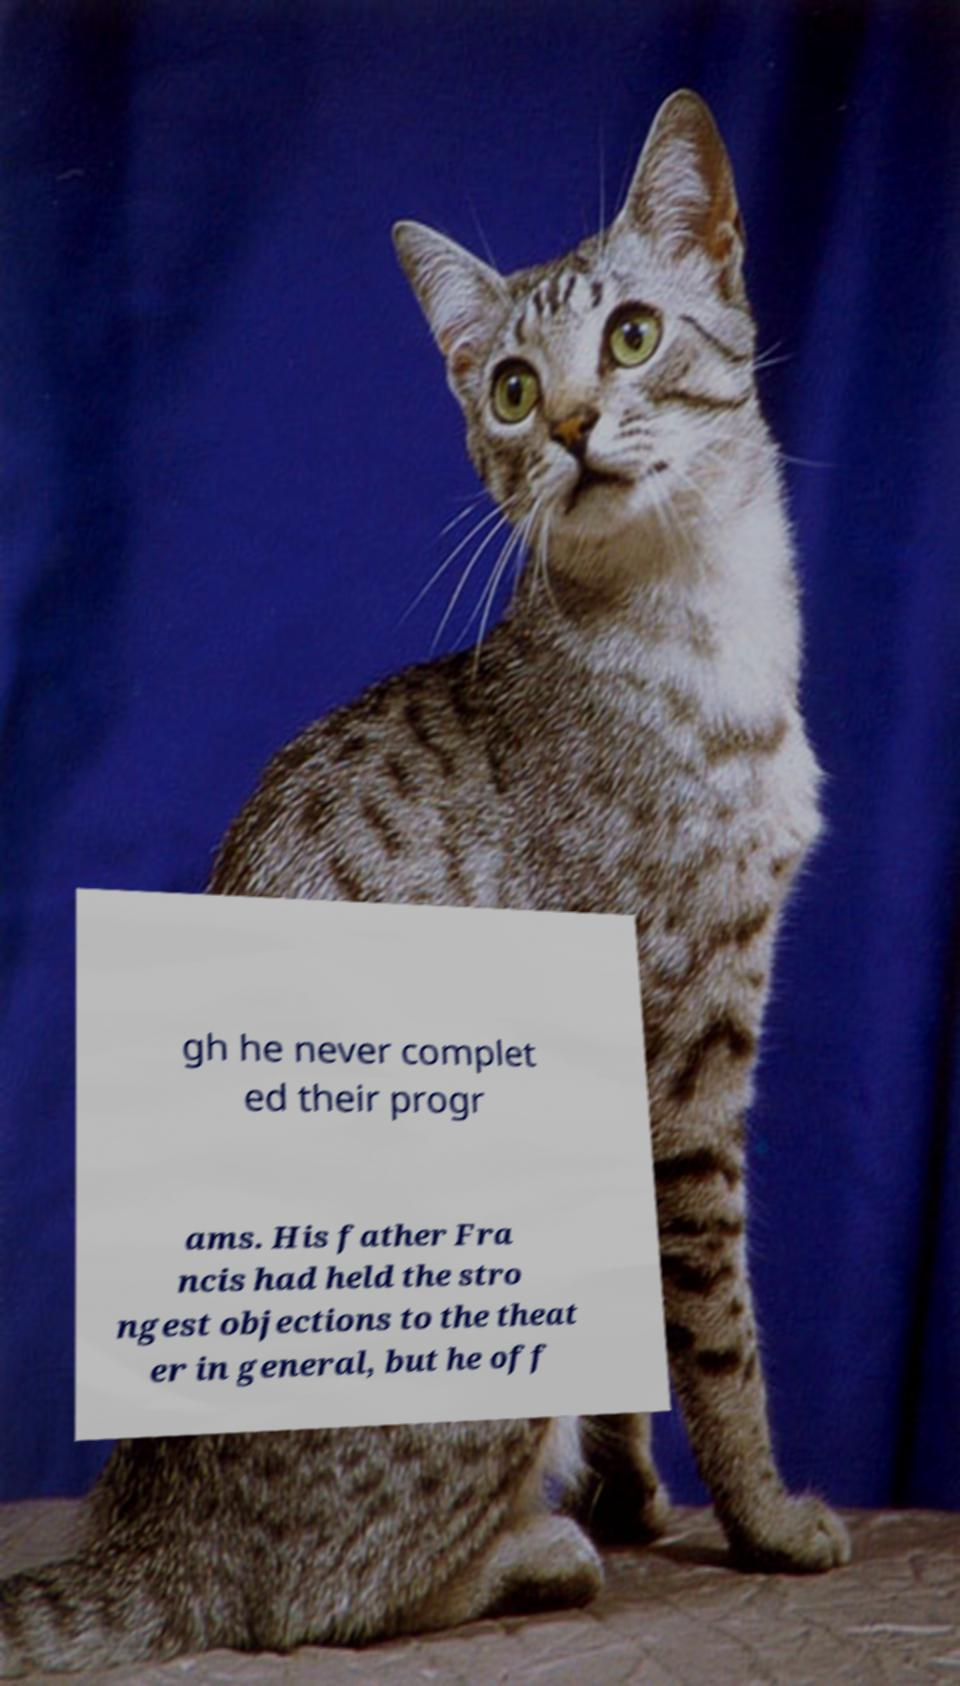There's text embedded in this image that I need extracted. Can you transcribe it verbatim? gh he never complet ed their progr ams. His father Fra ncis had held the stro ngest objections to the theat er in general, but he off 